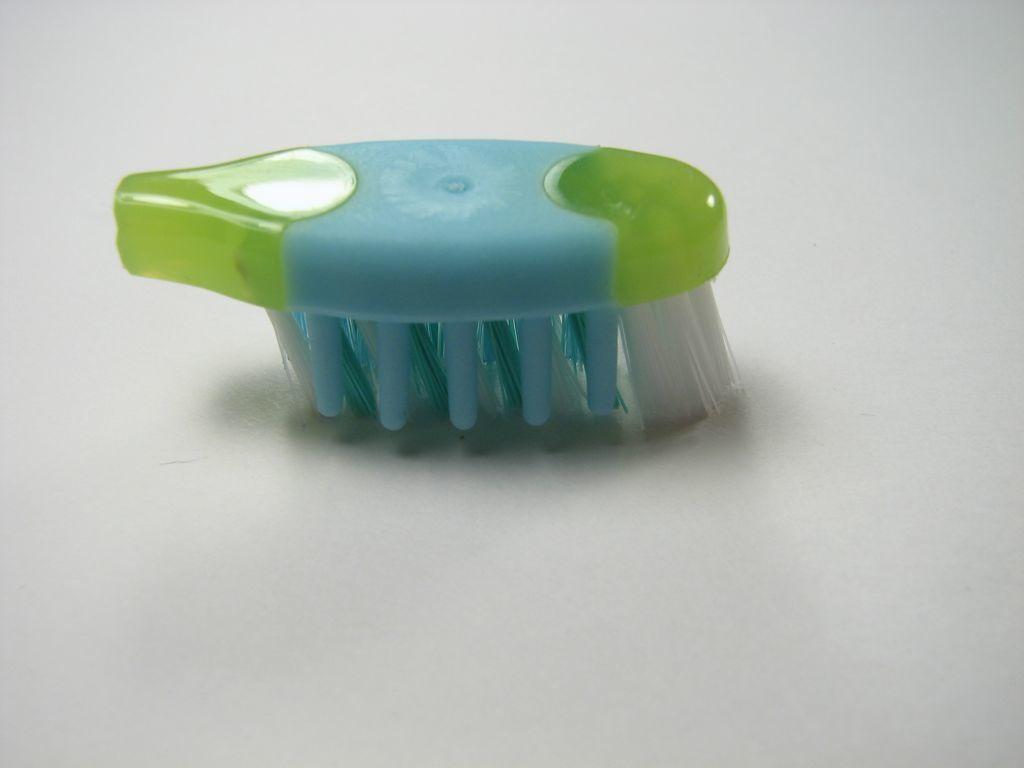Can you describe this image briefly? Here in this picture we can see the head of the toothbrush present on the floor over there and we can see it is in blue and green colored. 